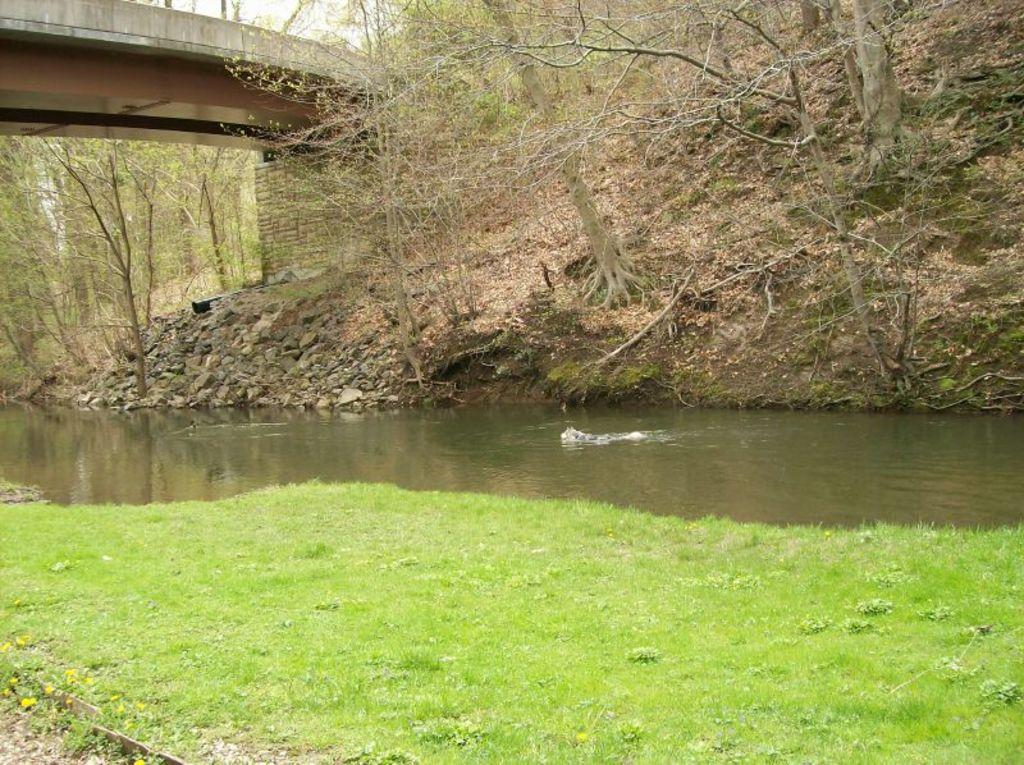What type of vegetation is present in the front portion of the image? There is grass in the front portion of the image. What natural element is also present in the front portion of the image? There is water in the front portion of the image. What type of vegetation can be seen in the background portion of the image? There are trees in the background portion of the image. What other objects can be seen in the background portion of the image? There are rocks, a wall, and a bridge in the background portion of the image. What type of twig can be seen floating on the water in the image? There is no twig present in the image; the water is not shown to have any floating objects. 